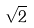Convert formula to latex. <formula><loc_0><loc_0><loc_500><loc_500>\sqrt { 2 }</formula> 